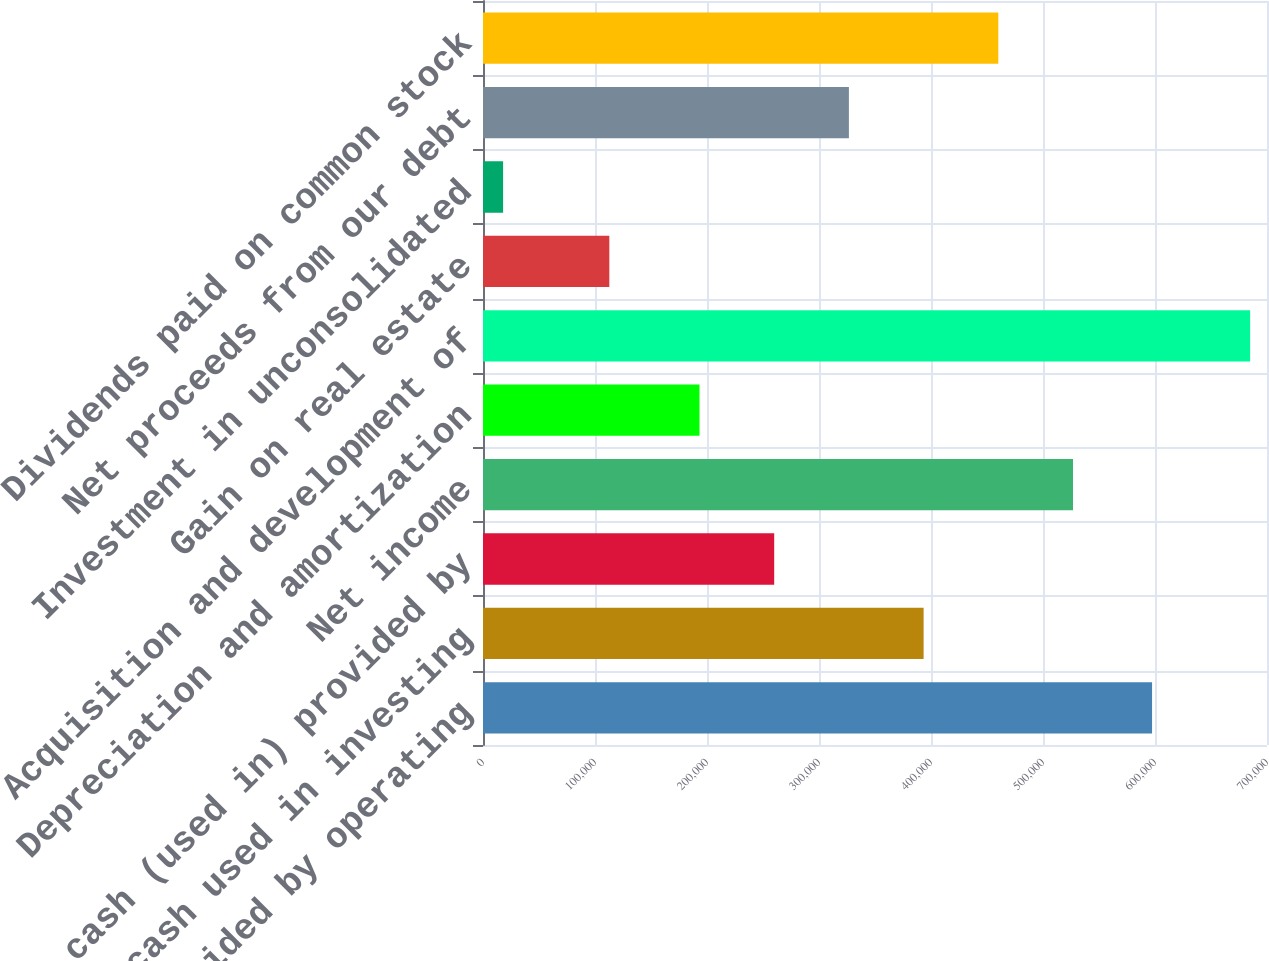Convert chart. <chart><loc_0><loc_0><loc_500><loc_500><bar_chart><fcel>Net cash provided by operating<fcel>Net cash used in investing<fcel>Net cash (used in) provided by<fcel>Net income<fcel>Depreciation and amortization<fcel>Acquisition and development of<fcel>Gain on real estate<fcel>Investment in unconsolidated<fcel>Net proceeds from our debt<fcel>Dividends paid on common stock<nl><fcel>597375<fcel>393392<fcel>259995<fcel>526790<fcel>193296<fcel>684931<fcel>112789<fcel>17944<fcel>326693<fcel>460091<nl></chart> 